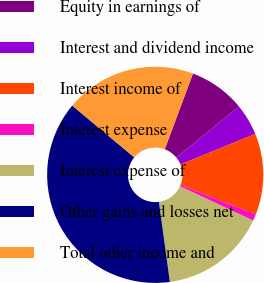<chart> <loc_0><loc_0><loc_500><loc_500><pie_chart><fcel>Equity in earnings of<fcel>Interest and dividend income<fcel>Interest income of<fcel>Interest expense<fcel>Interest expense of<fcel>Other gains and losses net<fcel>Total other income and<nl><fcel>8.43%<fcel>4.71%<fcel>12.16%<fcel>0.98%<fcel>15.88%<fcel>38.23%<fcel>19.61%<nl></chart> 